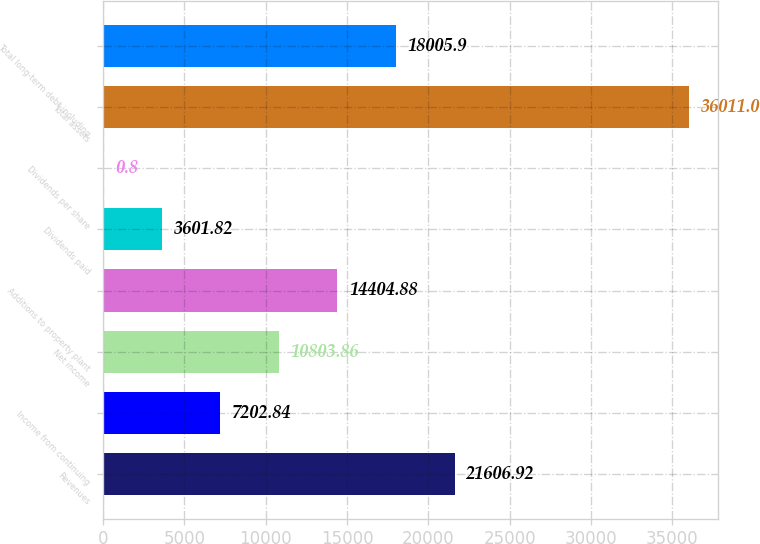Convert chart to OTSL. <chart><loc_0><loc_0><loc_500><loc_500><bar_chart><fcel>Revenues<fcel>Income from continuing<fcel>Net income<fcel>Additions to property plant<fcel>Dividends paid<fcel>Dividends per share<fcel>Total assets<fcel>Total long-term debt including<nl><fcel>21606.9<fcel>7202.84<fcel>10803.9<fcel>14404.9<fcel>3601.82<fcel>0.8<fcel>36011<fcel>18005.9<nl></chart> 